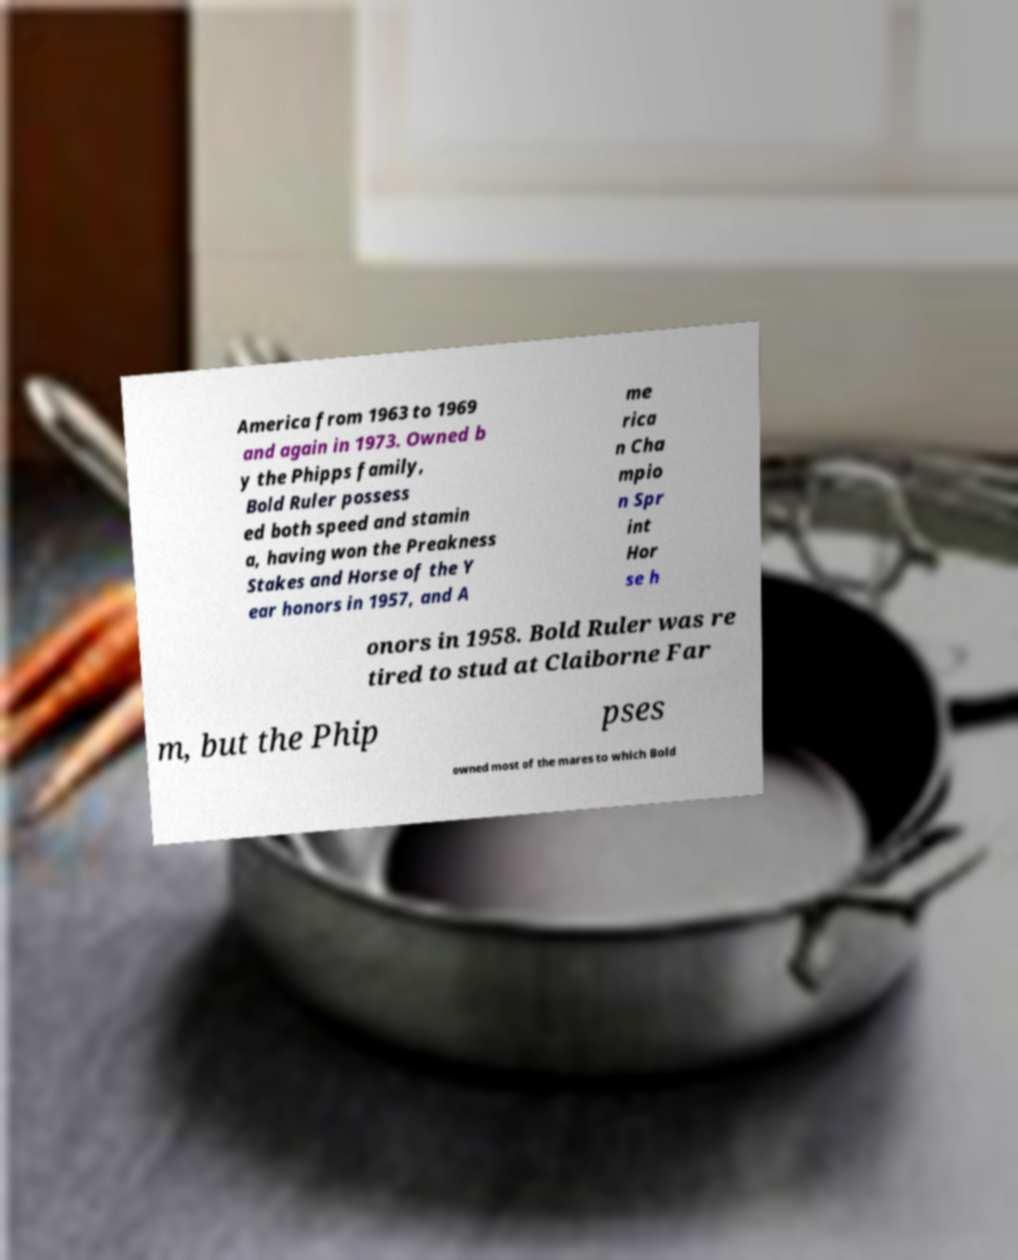Please identify and transcribe the text found in this image. America from 1963 to 1969 and again in 1973. Owned b y the Phipps family, Bold Ruler possess ed both speed and stamin a, having won the Preakness Stakes and Horse of the Y ear honors in 1957, and A me rica n Cha mpio n Spr int Hor se h onors in 1958. Bold Ruler was re tired to stud at Claiborne Far m, but the Phip pses owned most of the mares to which Bold 